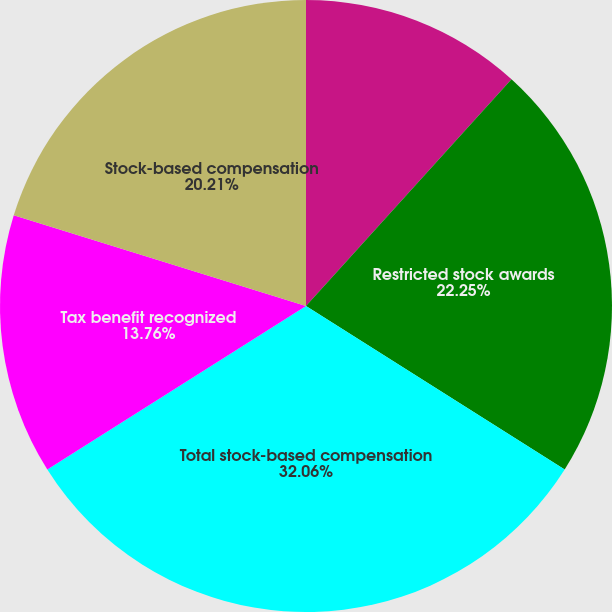Convert chart to OTSL. <chart><loc_0><loc_0><loc_500><loc_500><pie_chart><fcel>Stock options<fcel>Restricted stock awards<fcel>Total stock-based compensation<fcel>Tax benefit recognized<fcel>Stock-based compensation<nl><fcel>11.72%<fcel>22.25%<fcel>32.06%<fcel>13.76%<fcel>20.21%<nl></chart> 